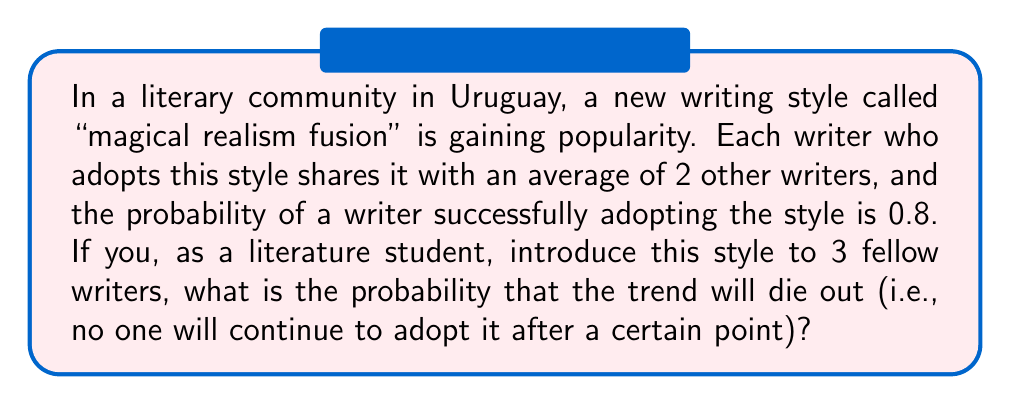Help me with this question. To solve this problem, we'll use the theory of branching processes:

1) In a branching process, the probability of extinction is given by the smallest non-negative root of the equation:
   
   $$f(s) = s$$
   
   where $f(s)$ is the probability generating function of the offspring distribution.

2) In this case, the offspring distribution follows a Binomial distribution with parameters $n=2$ (average number of writers each adopter shares with) and $p=0.8$ (probability of successful adoption).

3) The probability generating function for this distribution is:
   
   $$f(s) = (0.2 + 0.8s)^2$$

4) We need to solve the equation:
   
   $$(0.2 + 0.8s)^2 = s$$

5) Expanding this:
   
   $$0.04 + 0.32s + 0.64s^2 = s$$

6) Rearranging:
   
   $$0.64s^2 - 0.68s + 0.04 = 0$$

7) This is a quadratic equation. We can solve it using the quadratic formula:
   
   $$s = \frac{0.68 \pm \sqrt{0.68^2 - 4(0.64)(0.04)}}{2(0.64)}$$

8) Simplifying:
   
   $$s = \frac{0.68 \pm \sqrt{0.4624 - 0.1024}}{1.28} = \frac{0.68 \pm \sqrt{0.36}}{1.28} = \frac{0.68 \pm 0.6}{1.28}$$

9) This gives us two solutions: $s_1 = 1$ and $s_2 = 0.0625$

10) The probability of extinction is the smallest non-negative root, which is 0.0625.

11) However, this is the probability for a single initial adopter. We start with 3 initial adopters, so we need to cube this probability:

    $$0.0625^3 \approx 0.000244$$
Answer: $0.000244$ 